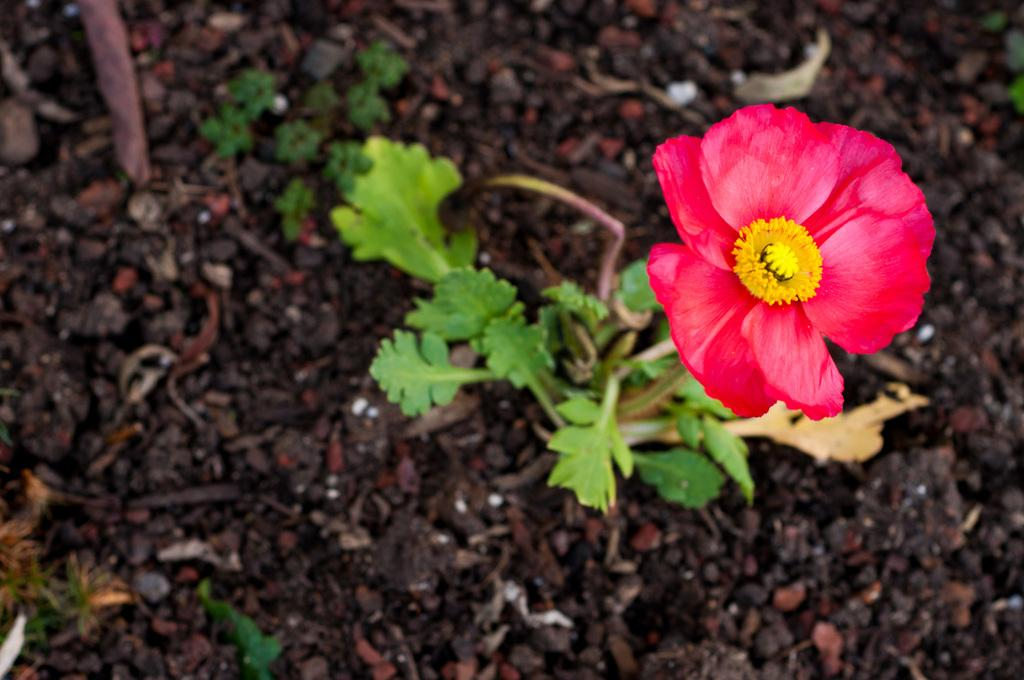What type of living organisms can be seen in the image? Plants can be seen in the image. Can you describe any specific features of the plants? There is a flower on one of the plants. What type of thread is being used to hold the duck in the image? There is no duck present in the image, so there is no thread being used to hold it. 